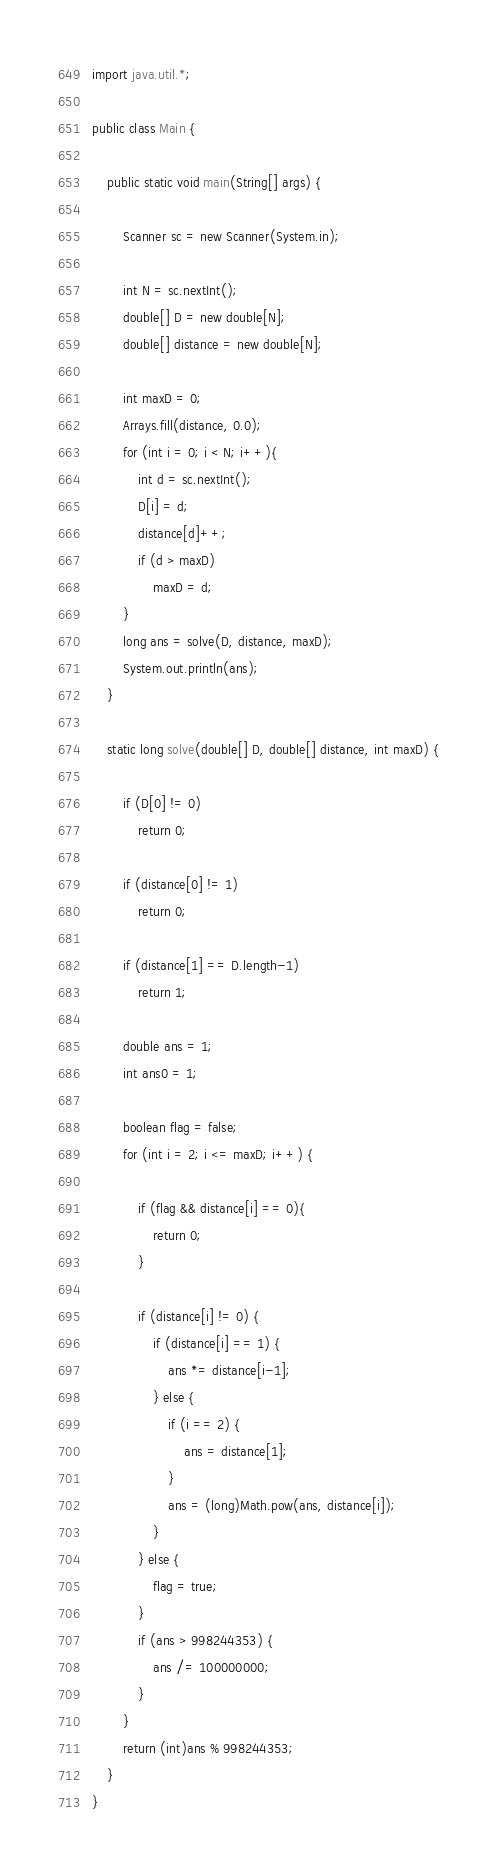<code> <loc_0><loc_0><loc_500><loc_500><_Java_>import java.util.*;

public class Main {

	public static void main(String[] args) {

		Scanner sc = new Scanner(System.in);

		int N = sc.nextInt();
		double[] D = new double[N];
		double[] distance = new double[N];

		int maxD = 0;
		Arrays.fill(distance, 0.0);
		for (int i = 0; i < N; i++){
			int d = sc.nextInt();
			D[i] = d;
			distance[d]++;
			if (d > maxD)
				maxD = d;
		}
		long ans = solve(D, distance, maxD);
		System.out.println(ans);
	}
	
	static long solve(double[] D, double[] distance, int maxD) {

		if (D[0] != 0) 
			return 0;

		if (distance[0] != 1)
			return 0;

		if (distance[1] == D.length-1) 
			return 1;

		double ans = 1;
		int ans0 = 1;

		boolean flag = false;
		for (int i = 2; i <= maxD; i++) {

			if (flag && distance[i] == 0){
				return 0;
			}
			
			if (distance[i] != 0) {
				if (distance[i] == 1) {
					ans *= distance[i-1];
				} else {
					if (i == 2) {
						ans = distance[1];
					}
					ans = (long)Math.pow(ans, distance[i]);
				}
			} else {
				flag = true;
			}
			if (ans > 998244353) {
				ans /= 100000000;
			}
		}	 
		return (int)ans % 998244353;
	}
}</code> 